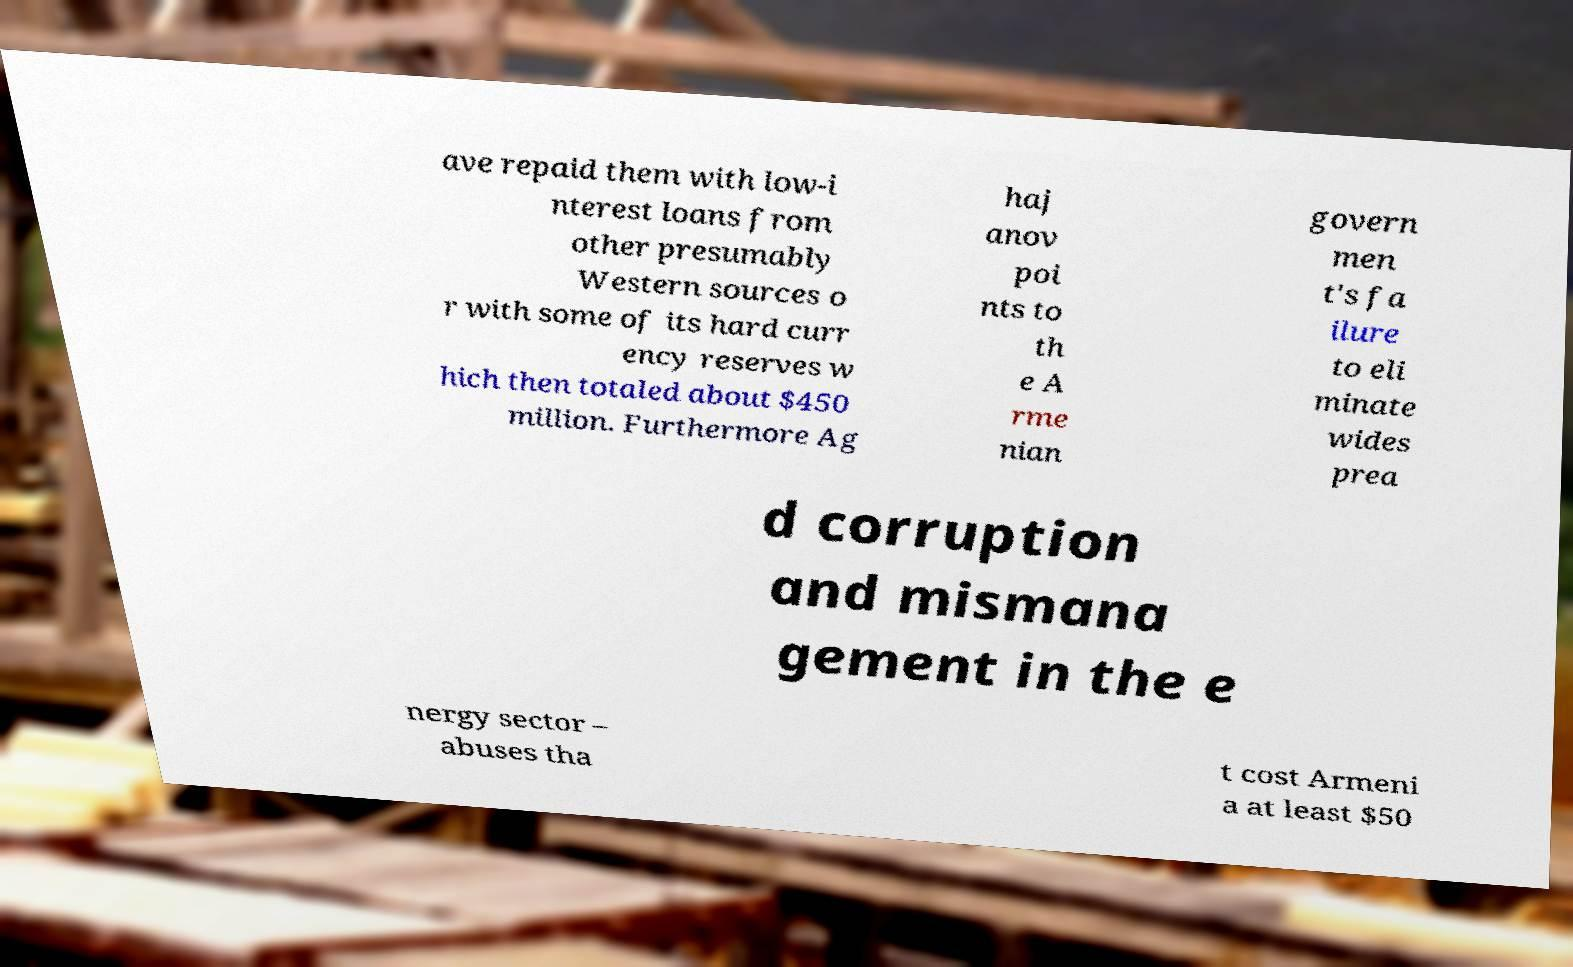What messages or text are displayed in this image? I need them in a readable, typed format. ave repaid them with low-i nterest loans from other presumably Western sources o r with some of its hard curr ency reserves w hich then totaled about $450 million. Furthermore Ag haj anov poi nts to th e A rme nian govern men t's fa ilure to eli minate wides prea d corruption and mismana gement in the e nergy sector – abuses tha t cost Armeni a at least $50 